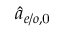<formula> <loc_0><loc_0><loc_500><loc_500>\hat { a } _ { e / o , 0 }</formula> 